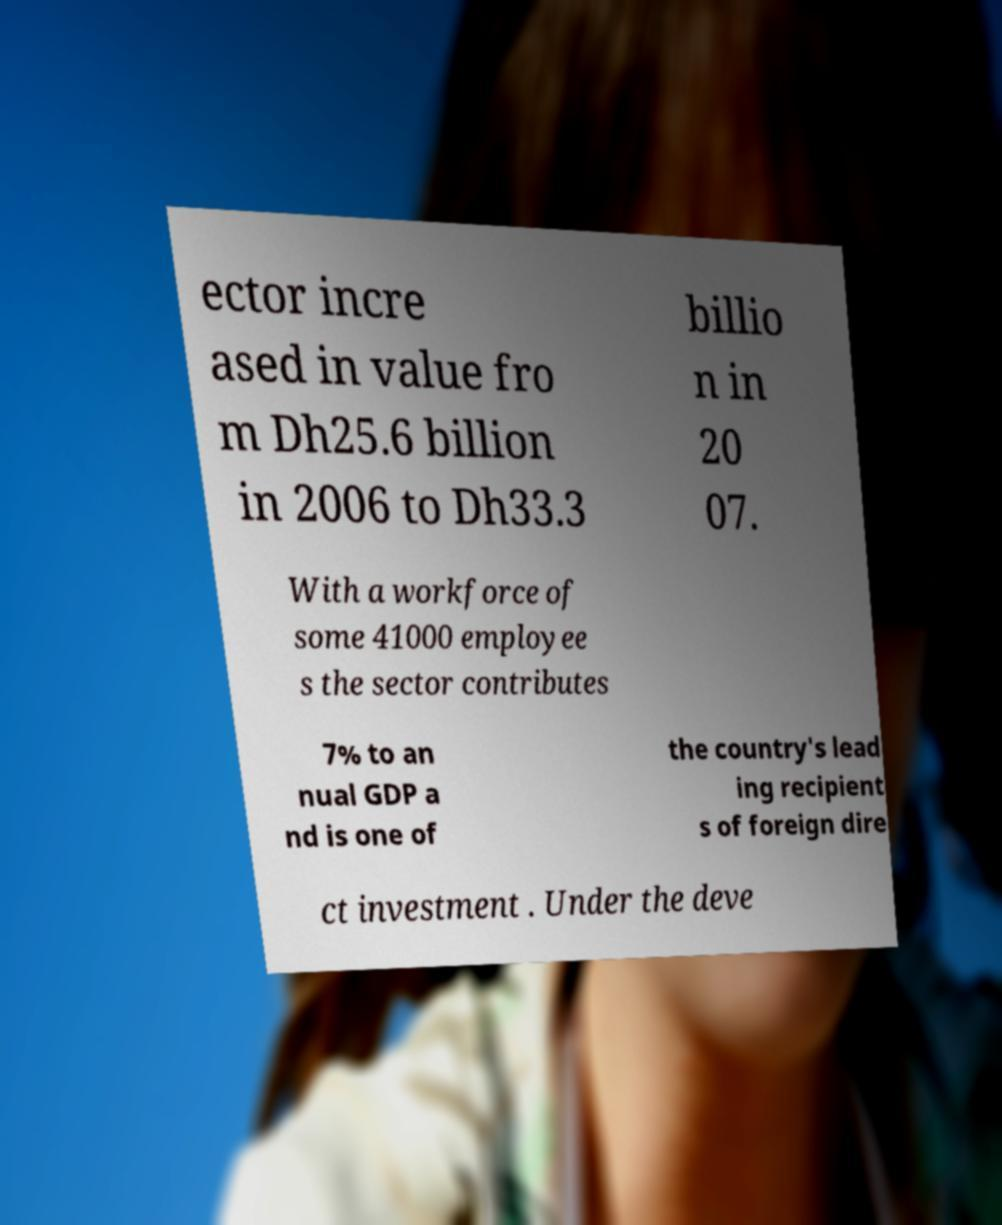Can you accurately transcribe the text from the provided image for me? ector incre ased in value fro m Dh25.6 billion in 2006 to Dh33.3 billio n in 20 07. With a workforce of some 41000 employee s the sector contributes 7% to an nual GDP a nd is one of the country's lead ing recipient s of foreign dire ct investment . Under the deve 